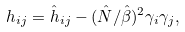Convert formula to latex. <formula><loc_0><loc_0><loc_500><loc_500>h _ { i j } = \hat { h } _ { i j } - ( \hat { N } / \hat { \beta } ) ^ { 2 } \gamma _ { i } \gamma _ { j } ,</formula> 